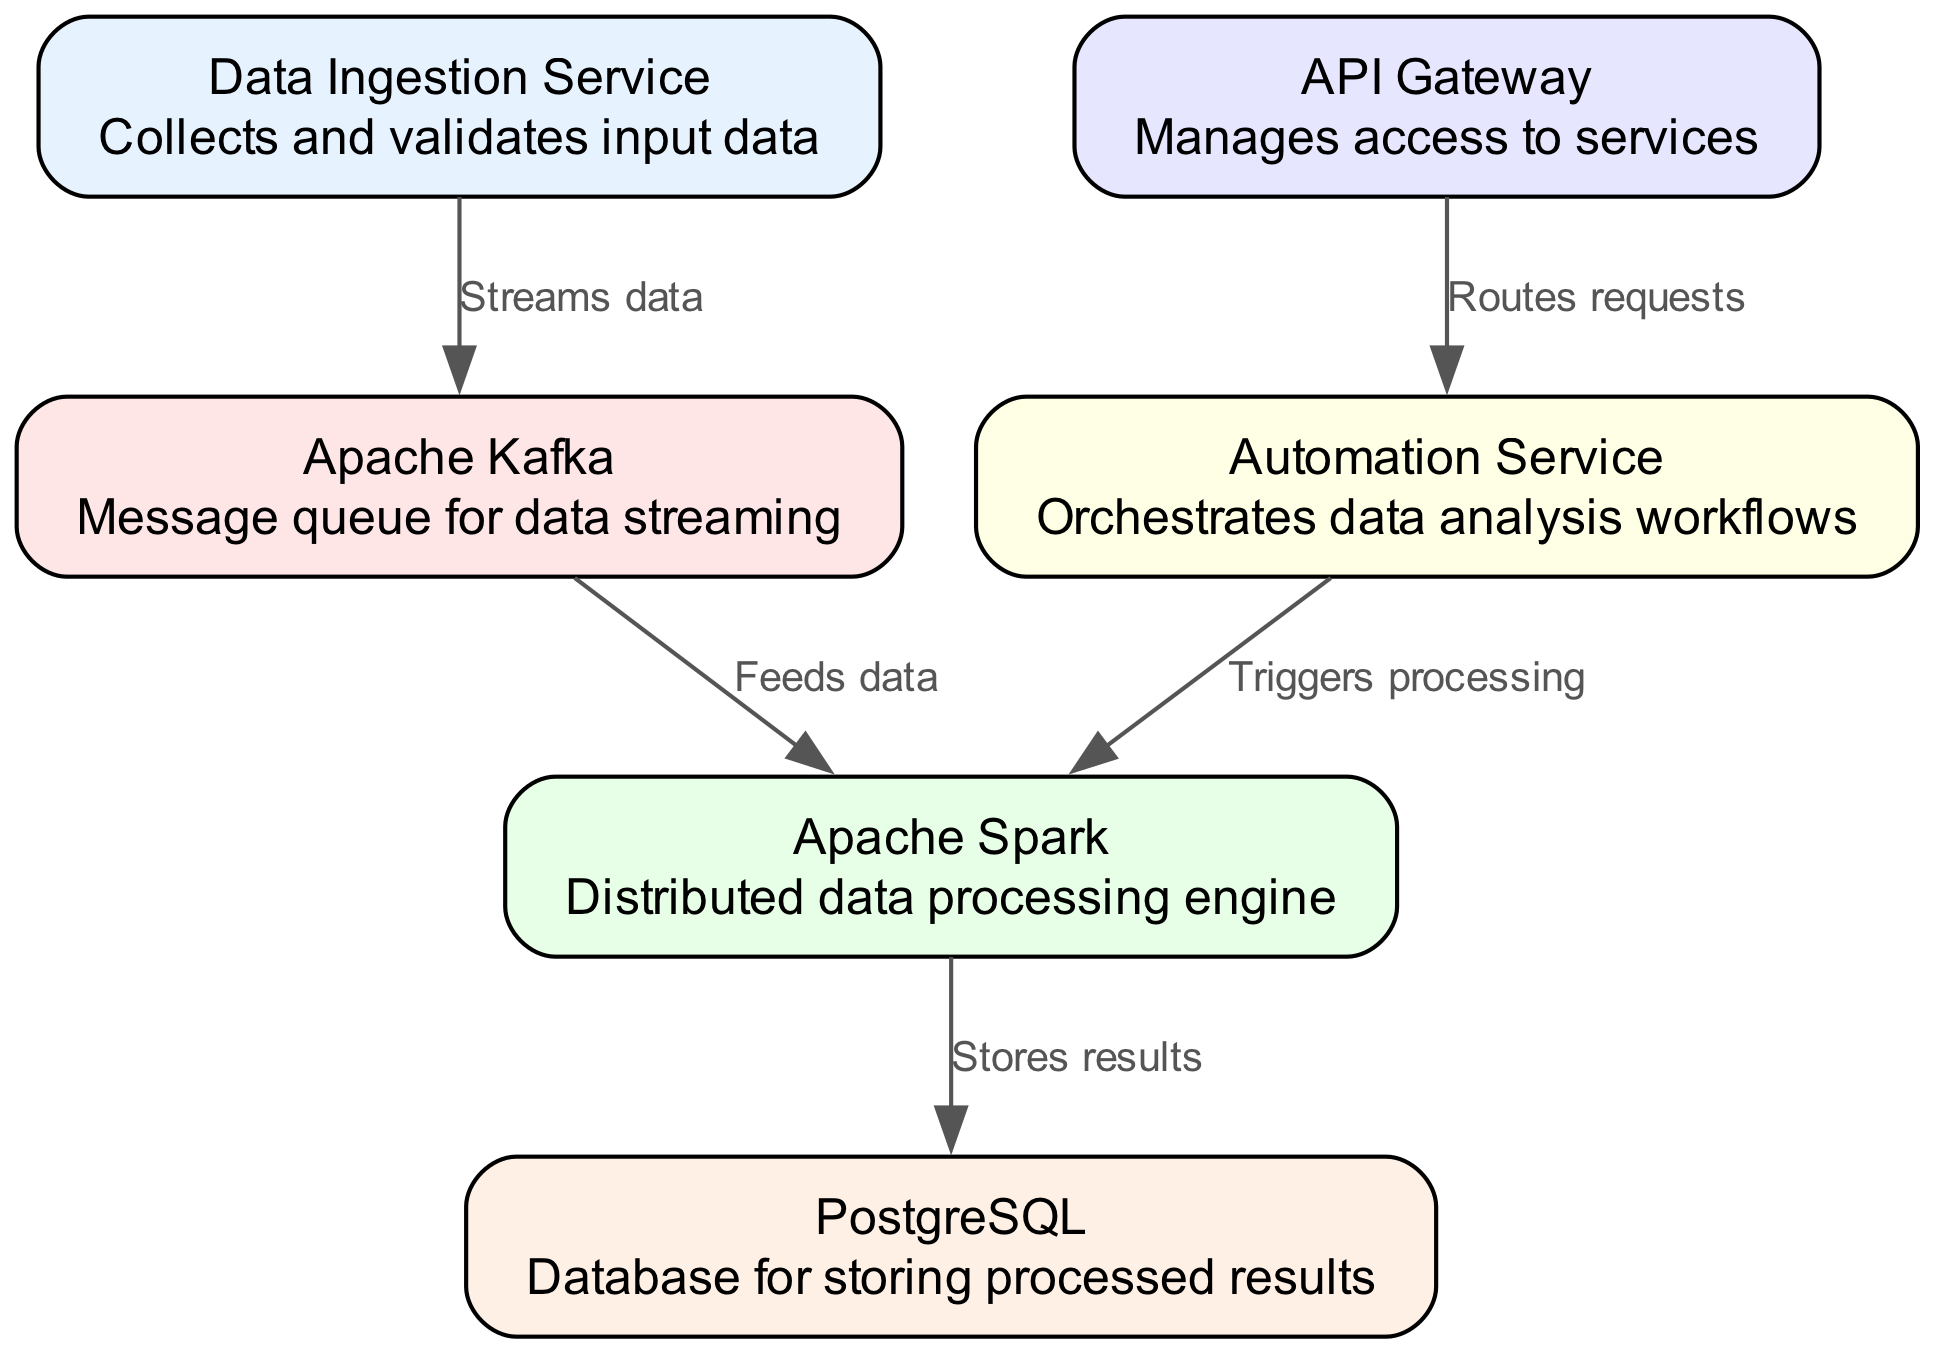What is the total number of nodes in the diagram? The diagram lists a total of six nodes: Data Ingestion Service, Apache Kafka, Apache Spark, PostgreSQL, API Gateway, and Automation Service.
Answer: Six Which node is responsible for storing results? The diagram indicates that Apache Spark is responsible for storing results, as it has an edge leading to PostgreSQL labeled "Stores results."
Answer: Apache Spark What type of service is used for data ingestion? According to the diagram, the service used for data ingestion is called Data Ingestion Service, which is explicitly stated in the diagram.
Answer: Data Ingestion Service How many edges are present in the diagram? The diagram includes five edges. Each edge connects different nodes and describes the interactions between them.
Answer: Five Which node does the Automation Service trigger for processing? The Automation Service triggers processing in the Apache Spark node, as indicated by the edge labeled "Triggers processing" connecting the two.
Answer: Apache Spark What role does the API Gateway play in the system? In the system, the API Gateway manages access to services, which is clarified in its description within the diagram.
Answer: Manages access to services Which service streams data to the message queue? The Data Ingestion Service is responsible for streaming data to the message queue, represented by the edge labeled "Streams data."
Answer: Data Ingestion Service What is the direction of data flow from Apache Kafka to Apache Spark? The direction of data flow from Apache Kafka to Apache Spark is from Kafka to Spark, indicating that Kafka feeds data into Spark for processing.
Answer: From Kafka to Spark What does the Automation Service do with the data processing engine? The Automation Service triggers processing in the data processing engine, stated in the labeled edge between Automation Service and Apache Spark.
Answer: Triggers processing 